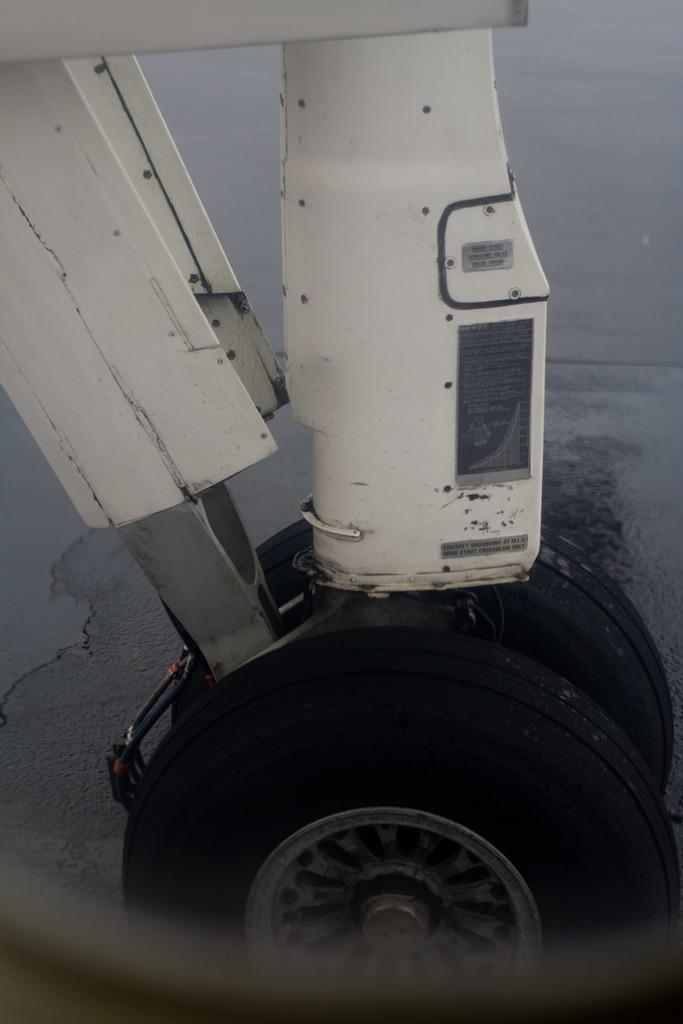What can be seen on the ground in the image? There are wheels on the ground in the image. What type of material are the objects made of? The objects are made of metal. How many boats are visible in the image? There are no boats present in the image. What type of calendar is shown in the image? There is no calendar present in the image. 